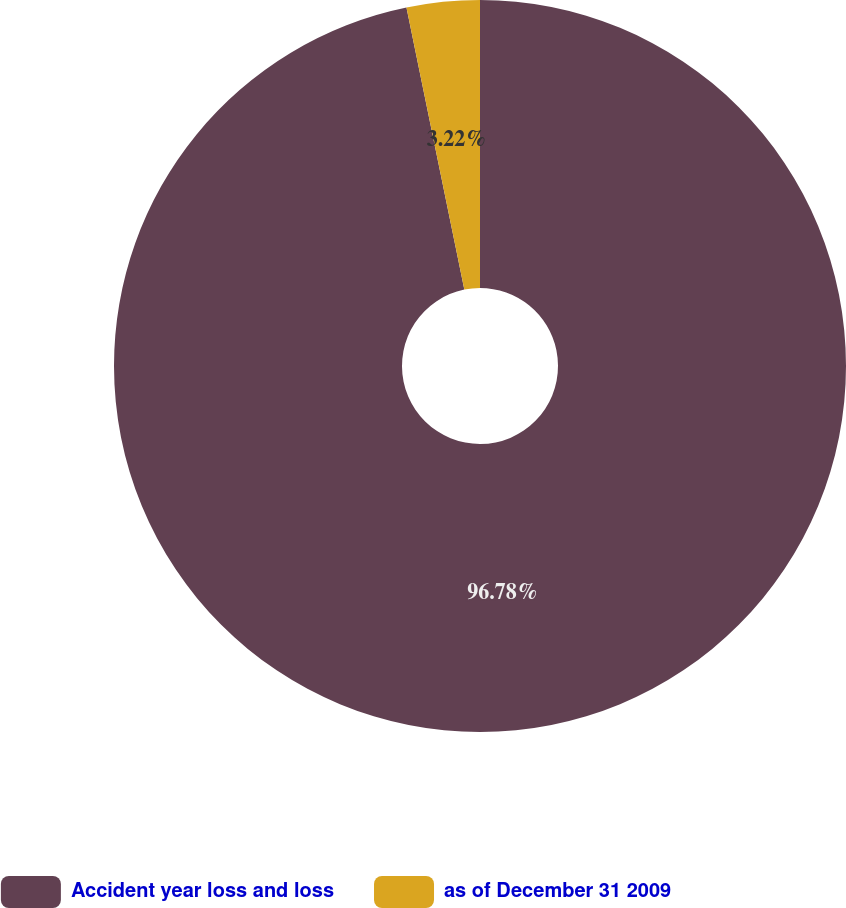<chart> <loc_0><loc_0><loc_500><loc_500><pie_chart><fcel>Accident year loss and loss<fcel>as of December 31 2009<nl><fcel>96.78%<fcel>3.22%<nl></chart> 